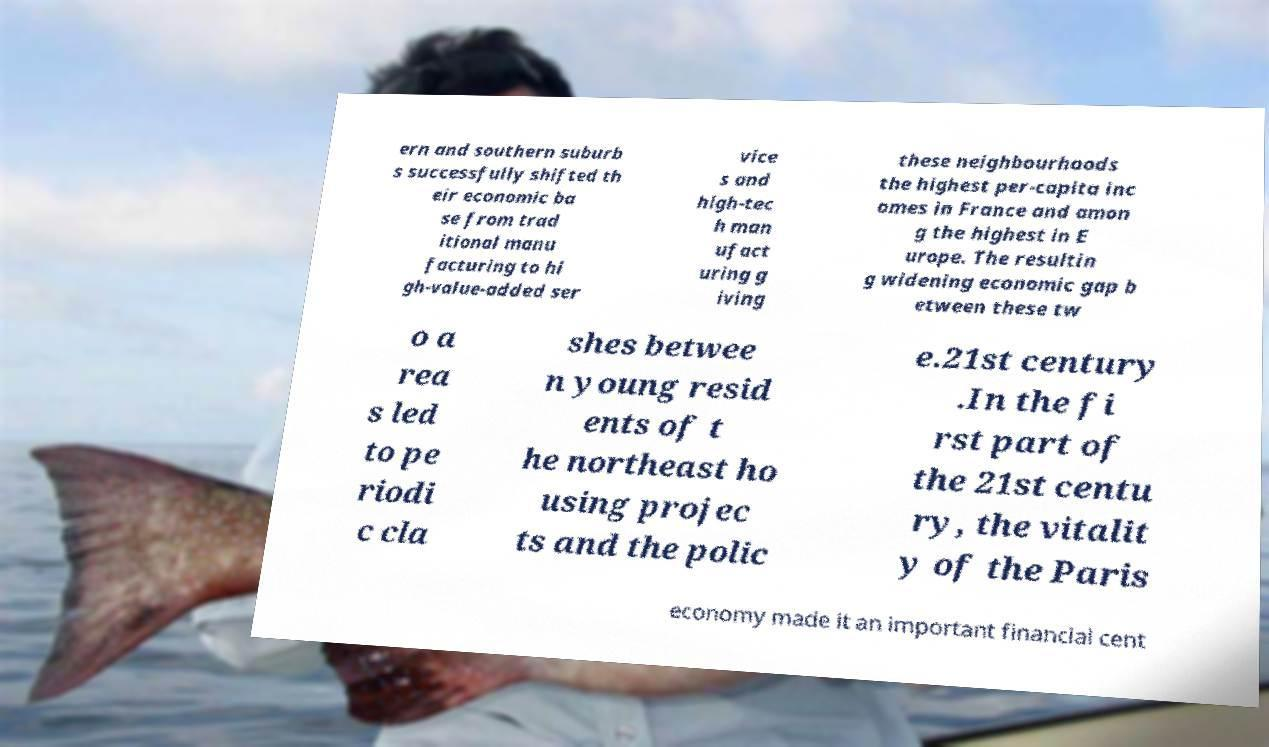Can you read and provide the text displayed in the image?This photo seems to have some interesting text. Can you extract and type it out for me? ern and southern suburb s successfully shifted th eir economic ba se from trad itional manu facturing to hi gh-value-added ser vice s and high-tec h man ufact uring g iving these neighbourhoods the highest per-capita inc omes in France and amon g the highest in E urope. The resultin g widening economic gap b etween these tw o a rea s led to pe riodi c cla shes betwee n young resid ents of t he northeast ho using projec ts and the polic e.21st century .In the fi rst part of the 21st centu ry, the vitalit y of the Paris economy made it an important financial cent 